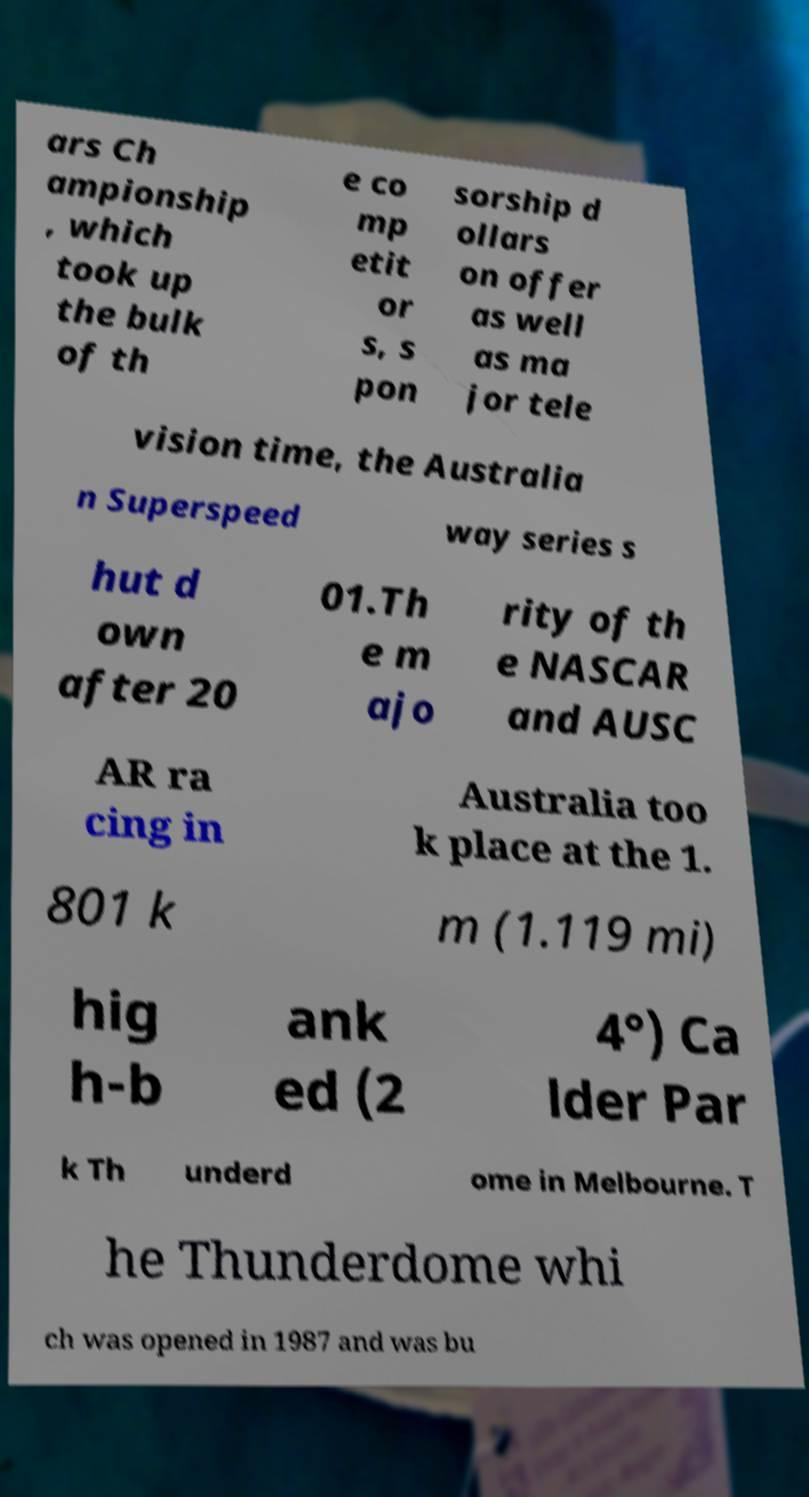Please read and relay the text visible in this image. What does it say? ars Ch ampionship , which took up the bulk of th e co mp etit or s, s pon sorship d ollars on offer as well as ma jor tele vision time, the Australia n Superspeed way series s hut d own after 20 01.Th e m ajo rity of th e NASCAR and AUSC AR ra cing in Australia too k place at the 1. 801 k m (1.119 mi) hig h-b ank ed (2 4°) Ca lder Par k Th underd ome in Melbourne. T he Thunderdome whi ch was opened in 1987 and was bu 